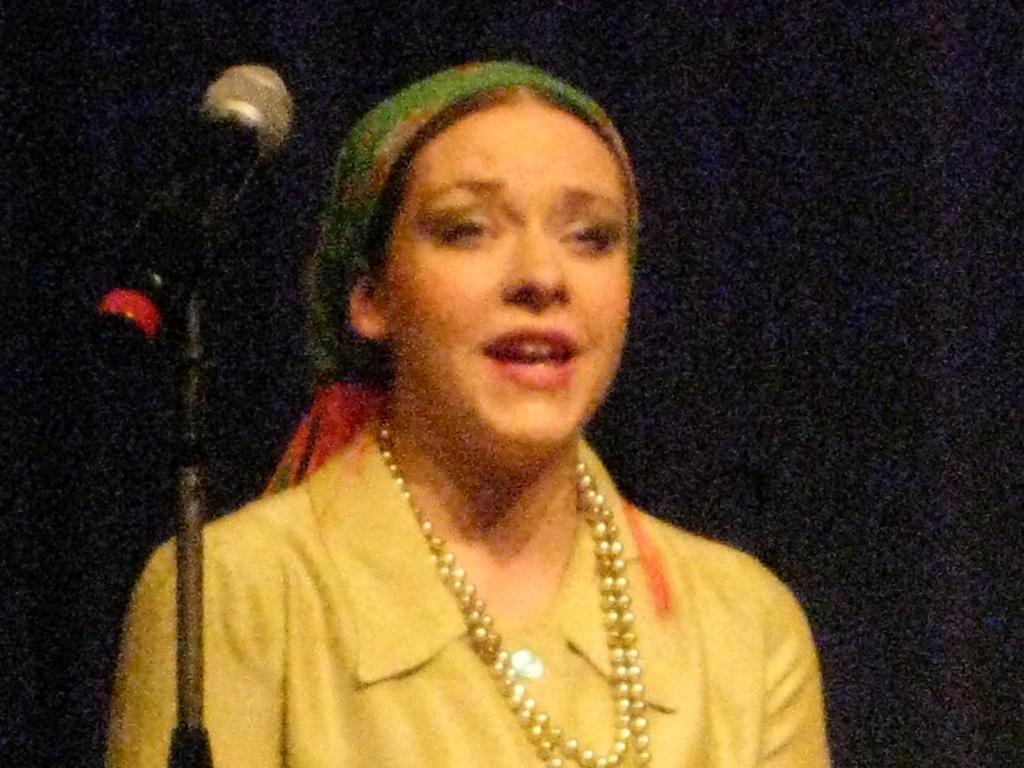Can you describe this image briefly? In this image I can see a person. On the left side I can see a mike. I can also see the background, is black in color. 